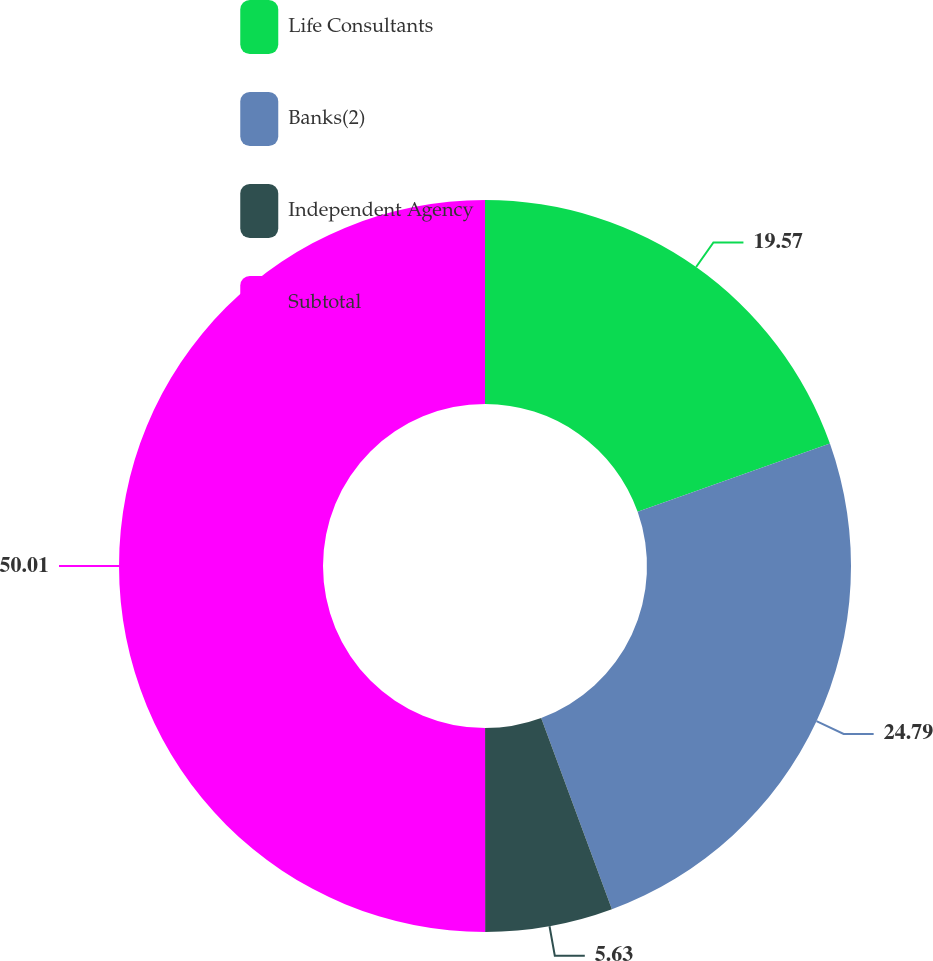<chart> <loc_0><loc_0><loc_500><loc_500><pie_chart><fcel>Life Consultants<fcel>Banks(2)<fcel>Independent Agency<fcel>Subtotal<nl><fcel>19.57%<fcel>24.79%<fcel>5.63%<fcel>50.0%<nl></chart> 